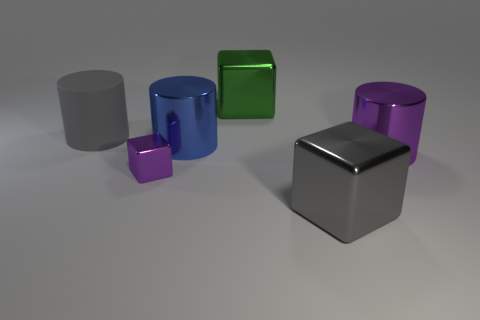How many other things are the same shape as the big green thing?
Ensure brevity in your answer.  2. Is there another purple object made of the same material as the tiny thing?
Provide a succinct answer. Yes. Is the big cube in front of the purple metal block made of the same material as the cylinder that is left of the tiny purple metallic object?
Keep it short and to the point. No. How many yellow objects are there?
Your answer should be compact. 0. What is the shape of the large metallic object behind the gray matte cylinder?
Offer a terse response. Cube. How many other objects are there of the same size as the green thing?
Keep it short and to the point. 4. Do the purple shiny object behind the purple cube and the gray thing that is left of the small block have the same shape?
Offer a very short reply. Yes. What number of metallic objects are to the right of the green metallic object?
Your answer should be compact. 2. There is a big metal block that is on the right side of the large green metal object; what color is it?
Provide a succinct answer. Gray. The other big metallic thing that is the same shape as the gray metallic object is what color?
Keep it short and to the point. Green. 